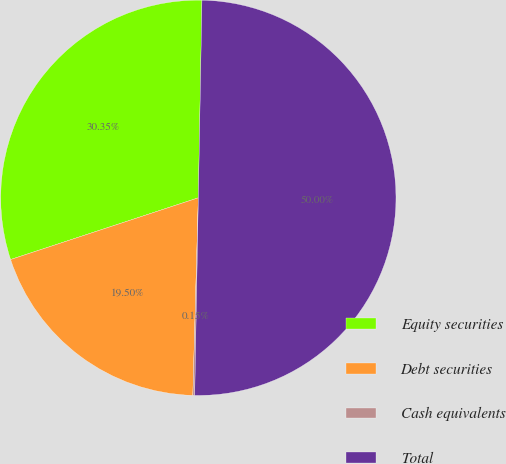Convert chart to OTSL. <chart><loc_0><loc_0><loc_500><loc_500><pie_chart><fcel>Equity securities<fcel>Debt securities<fcel>Cash equivalents<fcel>Total<nl><fcel>30.35%<fcel>19.5%<fcel>0.15%<fcel>50.0%<nl></chart> 